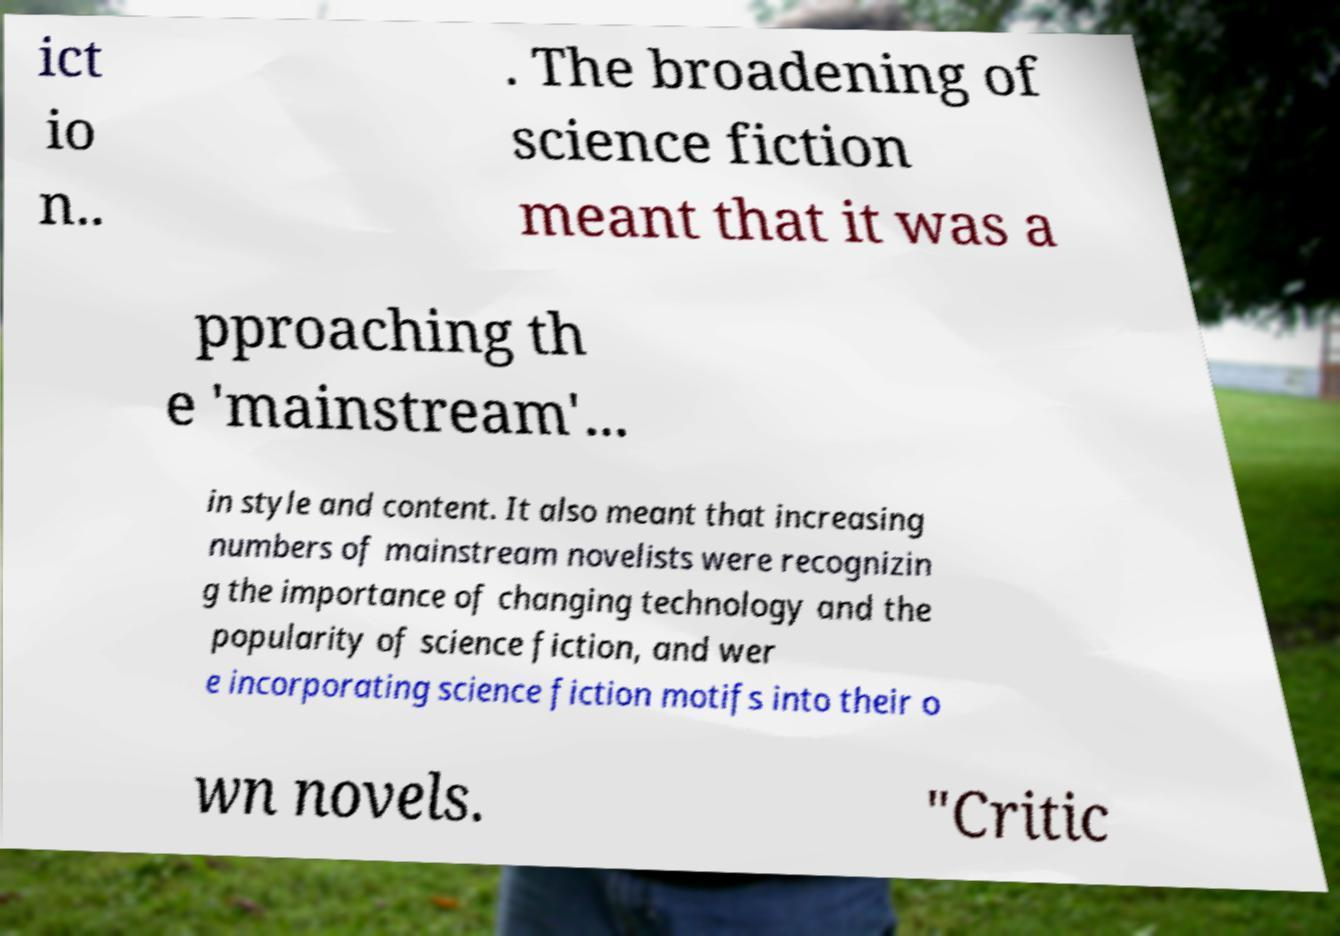For documentation purposes, I need the text within this image transcribed. Could you provide that? ict io n.. . The broadening of science fiction meant that it was a pproaching th e 'mainstream'... in style and content. It also meant that increasing numbers of mainstream novelists were recognizin g the importance of changing technology and the popularity of science fiction, and wer e incorporating science fiction motifs into their o wn novels. "Critic 